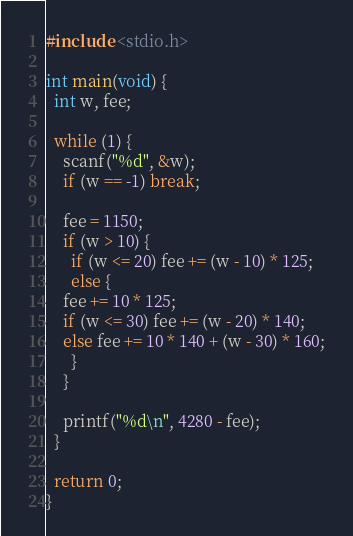<code> <loc_0><loc_0><loc_500><loc_500><_C_>#include <stdio.h>

int main(void) {
  int w, fee;

  while (1) {
    scanf("%d", &w);
    if (w == -1) break;
    
    fee = 1150;
    if (w > 10) {
      if (w <= 20) fee += (w - 10) * 125;
      else {
	fee += 10 * 125;
	if (w <= 30) fee += (w - 20) * 140;
	else fee += 10 * 140 + (w - 30) * 160;
      }
    }

    printf("%d\n", 4280 - fee);
  }

  return 0;
}</code> 